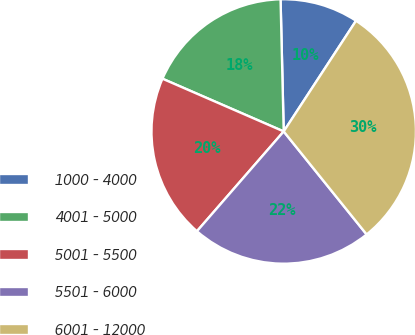Convert chart to OTSL. <chart><loc_0><loc_0><loc_500><loc_500><pie_chart><fcel>1000 - 4000<fcel>4001 - 5000<fcel>5001 - 5500<fcel>5501 - 6000<fcel>6001 - 12000<nl><fcel>9.59%<fcel>18.09%<fcel>20.14%<fcel>22.18%<fcel>30.0%<nl></chart> 